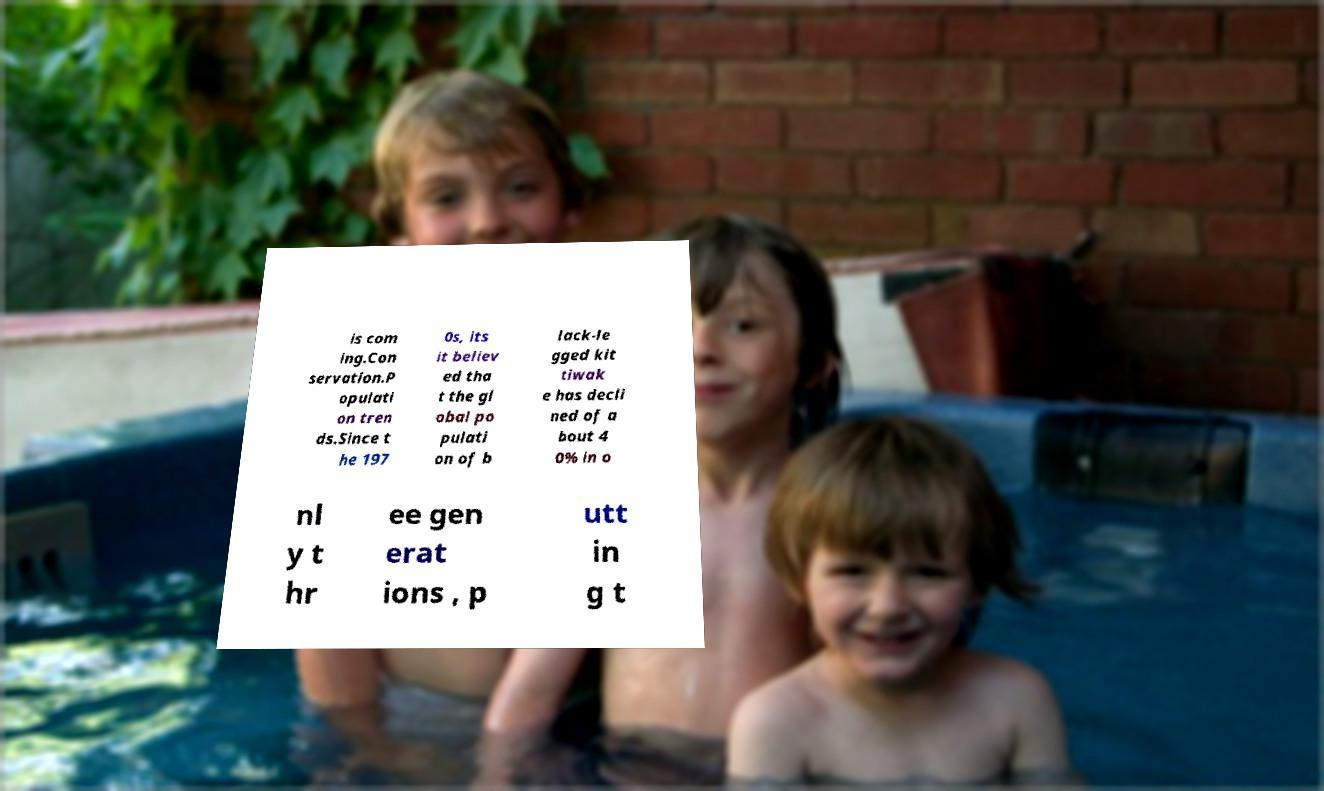Can you read and provide the text displayed in the image?This photo seems to have some interesting text. Can you extract and type it out for me? is com ing.Con servation.P opulati on tren ds.Since t he 197 0s, its it believ ed tha t the gl obal po pulati on of b lack-le gged kit tiwak e has decli ned of a bout 4 0% in o nl y t hr ee gen erat ions , p utt in g t 